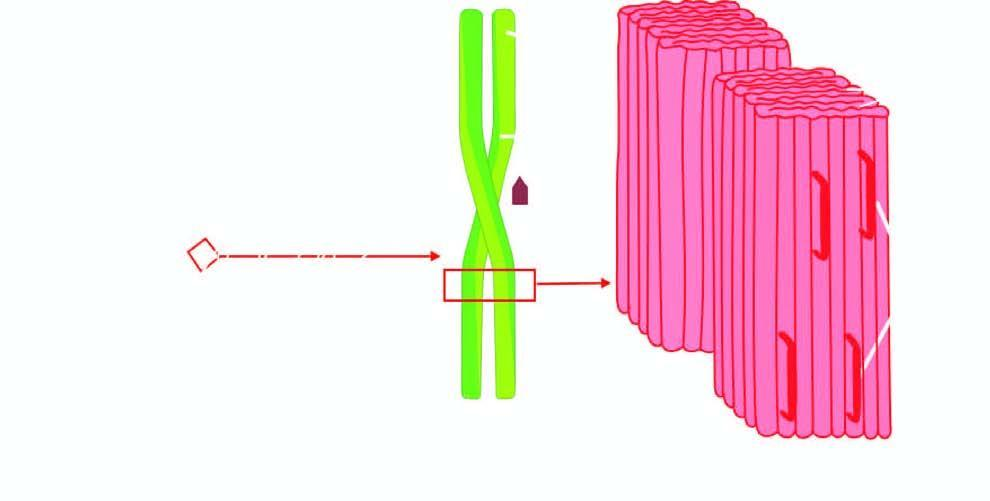s each fibril further composed of double helix of two pleated sheets in the form of twin filaments separated by a clear space?
Answer the question using a single word or phrase. Yes 